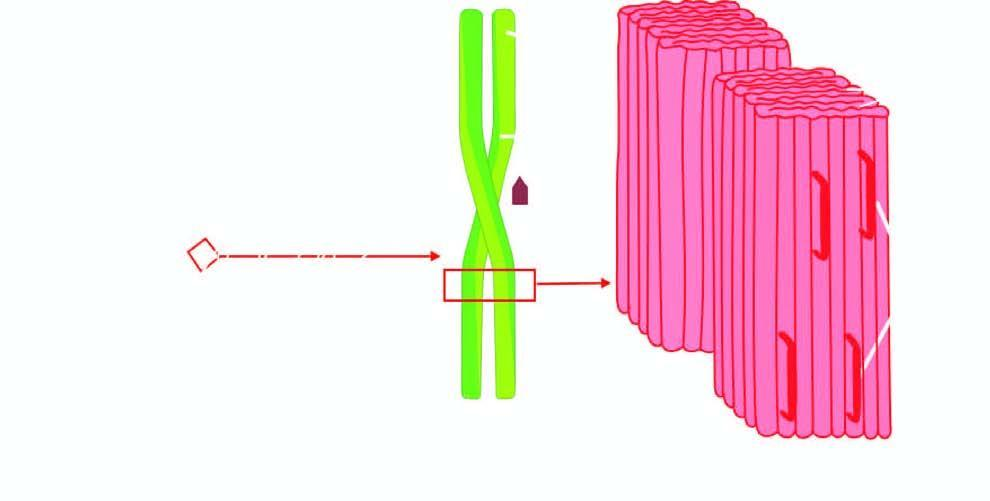s each fibril further composed of double helix of two pleated sheets in the form of twin filaments separated by a clear space?
Answer the question using a single word or phrase. Yes 